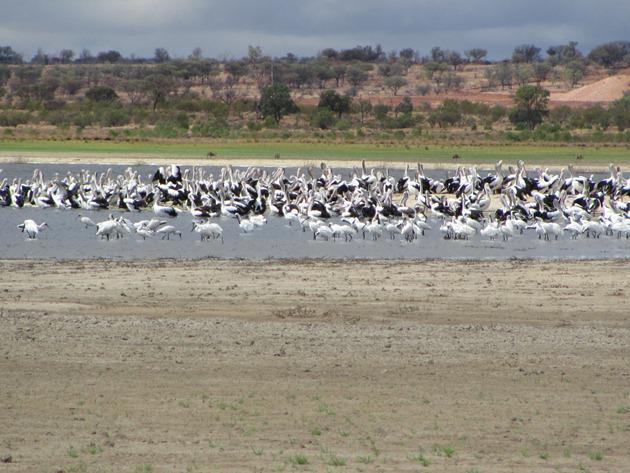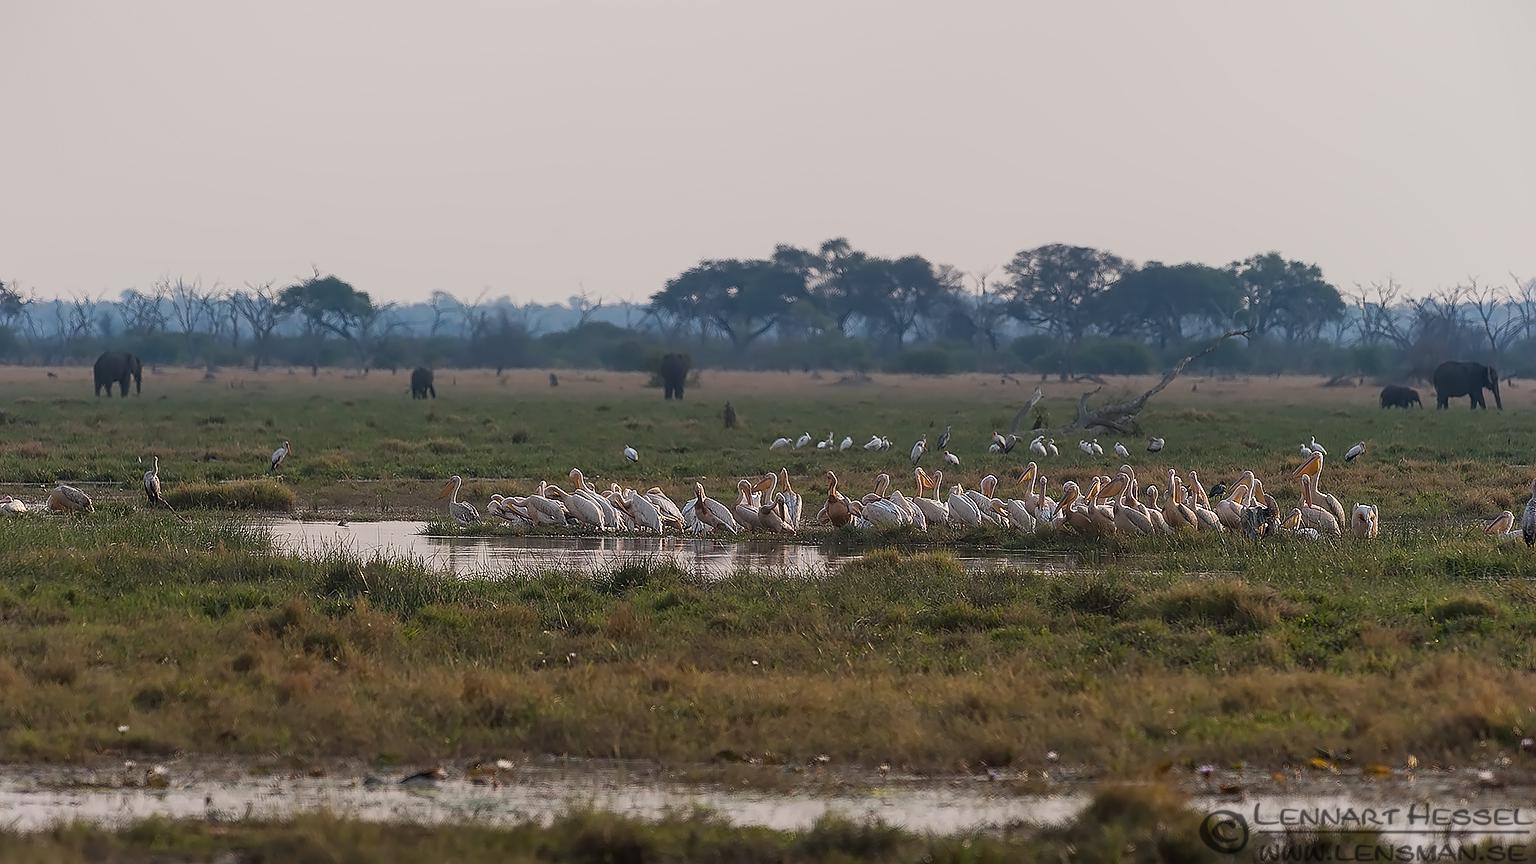The first image is the image on the left, the second image is the image on the right. Examine the images to the left and right. Is the description "The image on the right contains an animal that is not a bird." accurate? Answer yes or no. Yes. The first image is the image on the left, the second image is the image on the right. Considering the images on both sides, is "There is at least one picture where water is not visible." valid? Answer yes or no. No. 